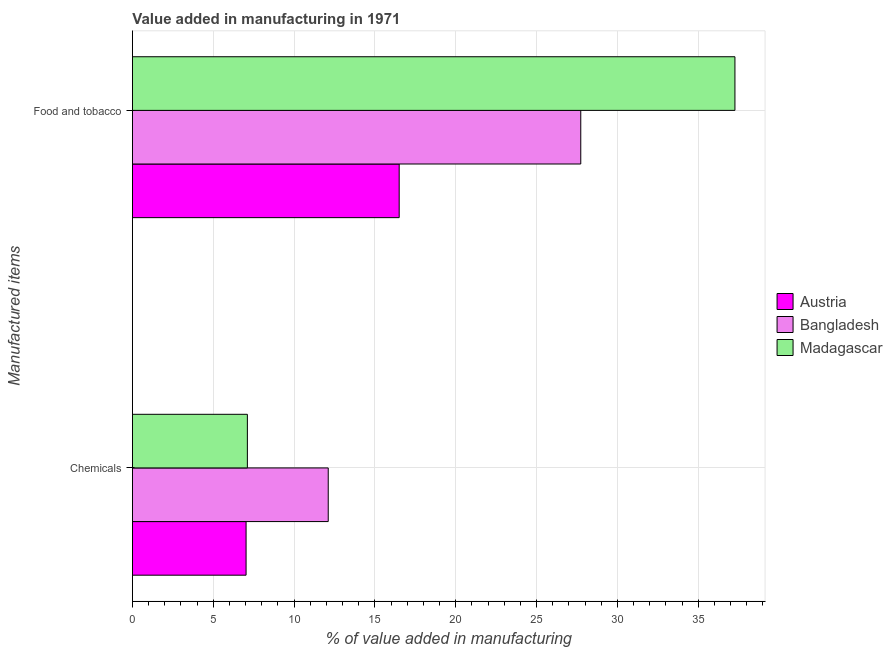How many groups of bars are there?
Your answer should be very brief. 2. Are the number of bars per tick equal to the number of legend labels?
Provide a succinct answer. Yes. Are the number of bars on each tick of the Y-axis equal?
Your answer should be very brief. Yes. How many bars are there on the 2nd tick from the bottom?
Your answer should be very brief. 3. What is the label of the 2nd group of bars from the top?
Your response must be concise. Chemicals. What is the value added by manufacturing food and tobacco in Austria?
Keep it short and to the point. 16.5. Across all countries, what is the maximum value added by  manufacturing chemicals?
Ensure brevity in your answer.  12.11. Across all countries, what is the minimum value added by  manufacturing chemicals?
Your answer should be compact. 7.03. In which country was the value added by manufacturing food and tobacco maximum?
Make the answer very short. Madagascar. What is the total value added by  manufacturing chemicals in the graph?
Your response must be concise. 26.25. What is the difference between the value added by  manufacturing chemicals in Bangladesh and that in Austria?
Keep it short and to the point. 5.08. What is the difference between the value added by  manufacturing chemicals in Austria and the value added by manufacturing food and tobacco in Bangladesh?
Ensure brevity in your answer.  -20.7. What is the average value added by manufacturing food and tobacco per country?
Provide a succinct answer. 27.17. What is the difference between the value added by manufacturing food and tobacco and value added by  manufacturing chemicals in Bangladesh?
Your answer should be very brief. 15.62. In how many countries, is the value added by manufacturing food and tobacco greater than 25 %?
Ensure brevity in your answer.  2. What is the ratio of the value added by manufacturing food and tobacco in Madagascar to that in Austria?
Provide a short and direct response. 2.26. In how many countries, is the value added by manufacturing food and tobacco greater than the average value added by manufacturing food and tobacco taken over all countries?
Keep it short and to the point. 2. What does the 3rd bar from the top in Food and tobacco represents?
Your answer should be compact. Austria. What does the 3rd bar from the bottom in Chemicals represents?
Ensure brevity in your answer.  Madagascar. Are the values on the major ticks of X-axis written in scientific E-notation?
Make the answer very short. No. Does the graph contain any zero values?
Offer a terse response. No. How are the legend labels stacked?
Your response must be concise. Vertical. What is the title of the graph?
Your response must be concise. Value added in manufacturing in 1971. Does "Ukraine" appear as one of the legend labels in the graph?
Make the answer very short. No. What is the label or title of the X-axis?
Your response must be concise. % of value added in manufacturing. What is the label or title of the Y-axis?
Provide a short and direct response. Manufactured items. What is the % of value added in manufacturing of Austria in Chemicals?
Your answer should be very brief. 7.03. What is the % of value added in manufacturing of Bangladesh in Chemicals?
Your answer should be compact. 12.11. What is the % of value added in manufacturing of Madagascar in Chemicals?
Make the answer very short. 7.11. What is the % of value added in manufacturing in Austria in Food and tobacco?
Your answer should be compact. 16.5. What is the % of value added in manufacturing in Bangladesh in Food and tobacco?
Offer a terse response. 27.73. What is the % of value added in manufacturing in Madagascar in Food and tobacco?
Make the answer very short. 37.27. Across all Manufactured items, what is the maximum % of value added in manufacturing of Austria?
Provide a short and direct response. 16.5. Across all Manufactured items, what is the maximum % of value added in manufacturing in Bangladesh?
Ensure brevity in your answer.  27.73. Across all Manufactured items, what is the maximum % of value added in manufacturing in Madagascar?
Give a very brief answer. 37.27. Across all Manufactured items, what is the minimum % of value added in manufacturing in Austria?
Offer a terse response. 7.03. Across all Manufactured items, what is the minimum % of value added in manufacturing of Bangladesh?
Provide a short and direct response. 12.11. Across all Manufactured items, what is the minimum % of value added in manufacturing of Madagascar?
Your response must be concise. 7.11. What is the total % of value added in manufacturing of Austria in the graph?
Give a very brief answer. 23.53. What is the total % of value added in manufacturing in Bangladesh in the graph?
Keep it short and to the point. 39.85. What is the total % of value added in manufacturing of Madagascar in the graph?
Your response must be concise. 44.38. What is the difference between the % of value added in manufacturing in Austria in Chemicals and that in Food and tobacco?
Keep it short and to the point. -9.47. What is the difference between the % of value added in manufacturing of Bangladesh in Chemicals and that in Food and tobacco?
Make the answer very short. -15.62. What is the difference between the % of value added in manufacturing of Madagascar in Chemicals and that in Food and tobacco?
Offer a terse response. -30.16. What is the difference between the % of value added in manufacturing in Austria in Chemicals and the % of value added in manufacturing in Bangladesh in Food and tobacco?
Offer a terse response. -20.7. What is the difference between the % of value added in manufacturing in Austria in Chemicals and the % of value added in manufacturing in Madagascar in Food and tobacco?
Your answer should be very brief. -30.24. What is the difference between the % of value added in manufacturing in Bangladesh in Chemicals and the % of value added in manufacturing in Madagascar in Food and tobacco?
Your answer should be compact. -25.16. What is the average % of value added in manufacturing of Austria per Manufactured items?
Your response must be concise. 11.77. What is the average % of value added in manufacturing of Bangladesh per Manufactured items?
Your answer should be compact. 19.92. What is the average % of value added in manufacturing of Madagascar per Manufactured items?
Provide a short and direct response. 22.19. What is the difference between the % of value added in manufacturing in Austria and % of value added in manufacturing in Bangladesh in Chemicals?
Provide a short and direct response. -5.08. What is the difference between the % of value added in manufacturing in Austria and % of value added in manufacturing in Madagascar in Chemicals?
Give a very brief answer. -0.08. What is the difference between the % of value added in manufacturing of Bangladesh and % of value added in manufacturing of Madagascar in Chemicals?
Give a very brief answer. 5. What is the difference between the % of value added in manufacturing in Austria and % of value added in manufacturing in Bangladesh in Food and tobacco?
Keep it short and to the point. -11.23. What is the difference between the % of value added in manufacturing in Austria and % of value added in manufacturing in Madagascar in Food and tobacco?
Provide a short and direct response. -20.77. What is the difference between the % of value added in manufacturing of Bangladesh and % of value added in manufacturing of Madagascar in Food and tobacco?
Provide a succinct answer. -9.54. What is the ratio of the % of value added in manufacturing in Austria in Chemicals to that in Food and tobacco?
Your answer should be very brief. 0.43. What is the ratio of the % of value added in manufacturing in Bangladesh in Chemicals to that in Food and tobacco?
Make the answer very short. 0.44. What is the ratio of the % of value added in manufacturing in Madagascar in Chemicals to that in Food and tobacco?
Offer a terse response. 0.19. What is the difference between the highest and the second highest % of value added in manufacturing in Austria?
Your response must be concise. 9.47. What is the difference between the highest and the second highest % of value added in manufacturing in Bangladesh?
Give a very brief answer. 15.62. What is the difference between the highest and the second highest % of value added in manufacturing of Madagascar?
Your response must be concise. 30.16. What is the difference between the highest and the lowest % of value added in manufacturing in Austria?
Your answer should be compact. 9.47. What is the difference between the highest and the lowest % of value added in manufacturing in Bangladesh?
Make the answer very short. 15.62. What is the difference between the highest and the lowest % of value added in manufacturing in Madagascar?
Make the answer very short. 30.16. 